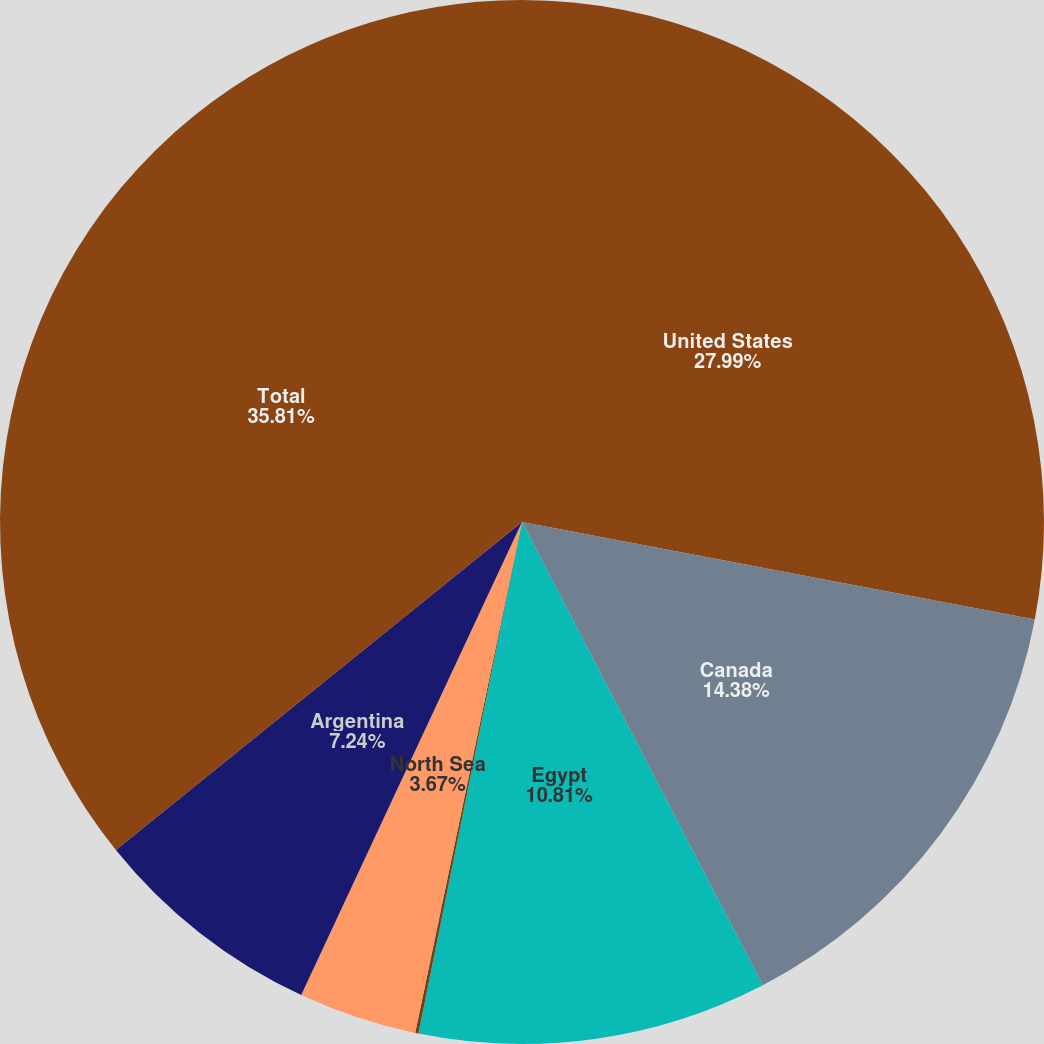Convert chart. <chart><loc_0><loc_0><loc_500><loc_500><pie_chart><fcel>United States<fcel>Canada<fcel>Egypt<fcel>Australia<fcel>North Sea<fcel>Argentina<fcel>Total<nl><fcel>27.99%<fcel>14.38%<fcel>10.81%<fcel>0.1%<fcel>3.67%<fcel>7.24%<fcel>35.81%<nl></chart> 